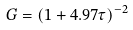<formula> <loc_0><loc_0><loc_500><loc_500>G = \left ( 1 + 4 . 9 7 \tau \right ) ^ { - 2 }</formula> 